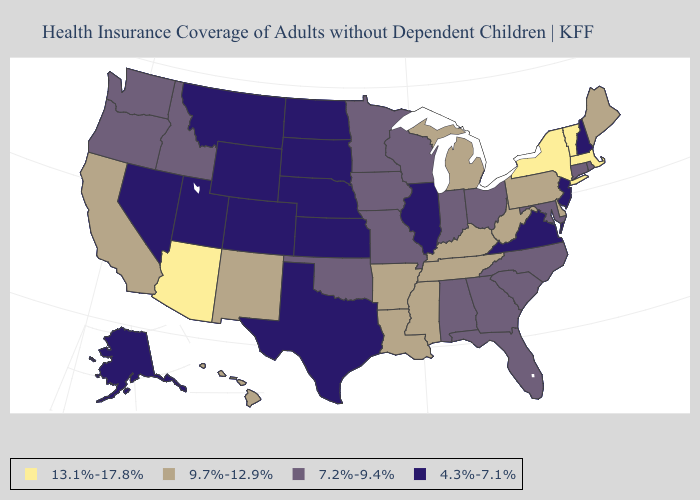Name the states that have a value in the range 4.3%-7.1%?
Keep it brief. Alaska, Colorado, Illinois, Kansas, Montana, Nebraska, Nevada, New Hampshire, New Jersey, North Dakota, South Dakota, Texas, Utah, Virginia, Wyoming. What is the lowest value in the Northeast?
Answer briefly. 4.3%-7.1%. What is the highest value in states that border Arizona?
Concise answer only. 9.7%-12.9%. What is the value of Georgia?
Keep it brief. 7.2%-9.4%. Name the states that have a value in the range 9.7%-12.9%?
Answer briefly. Arkansas, California, Delaware, Hawaii, Kentucky, Louisiana, Maine, Michigan, Mississippi, New Mexico, Pennsylvania, Tennessee, West Virginia. Does the map have missing data?
Be succinct. No. Which states have the lowest value in the South?
Short answer required. Texas, Virginia. Does Idaho have a lower value than Rhode Island?
Give a very brief answer. No. What is the value of Idaho?
Write a very short answer. 7.2%-9.4%. Does Minnesota have the lowest value in the MidWest?
Answer briefly. No. Name the states that have a value in the range 13.1%-17.8%?
Give a very brief answer. Arizona, Massachusetts, New York, Vermont. What is the value of Texas?
Write a very short answer. 4.3%-7.1%. Which states hav the highest value in the Northeast?
Keep it brief. Massachusetts, New York, Vermont. What is the lowest value in the MidWest?
Keep it brief. 4.3%-7.1%. What is the value of Connecticut?
Write a very short answer. 7.2%-9.4%. 